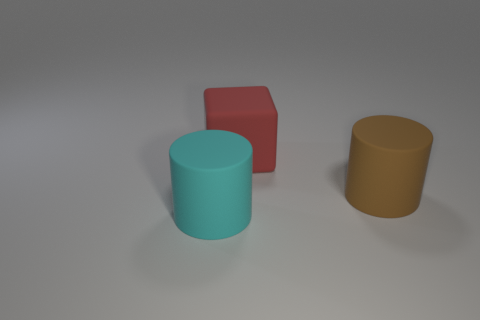Looking at the composition, what can you tell me about how the objects are arranged? The objects are spaced apart on a plain, light-colored surface, which draws attention to their shapes and colors. The arrangement is somewhat staggered, with the cylindrical objects in the foreground and the cube a little behind, creating a sense of depth. 